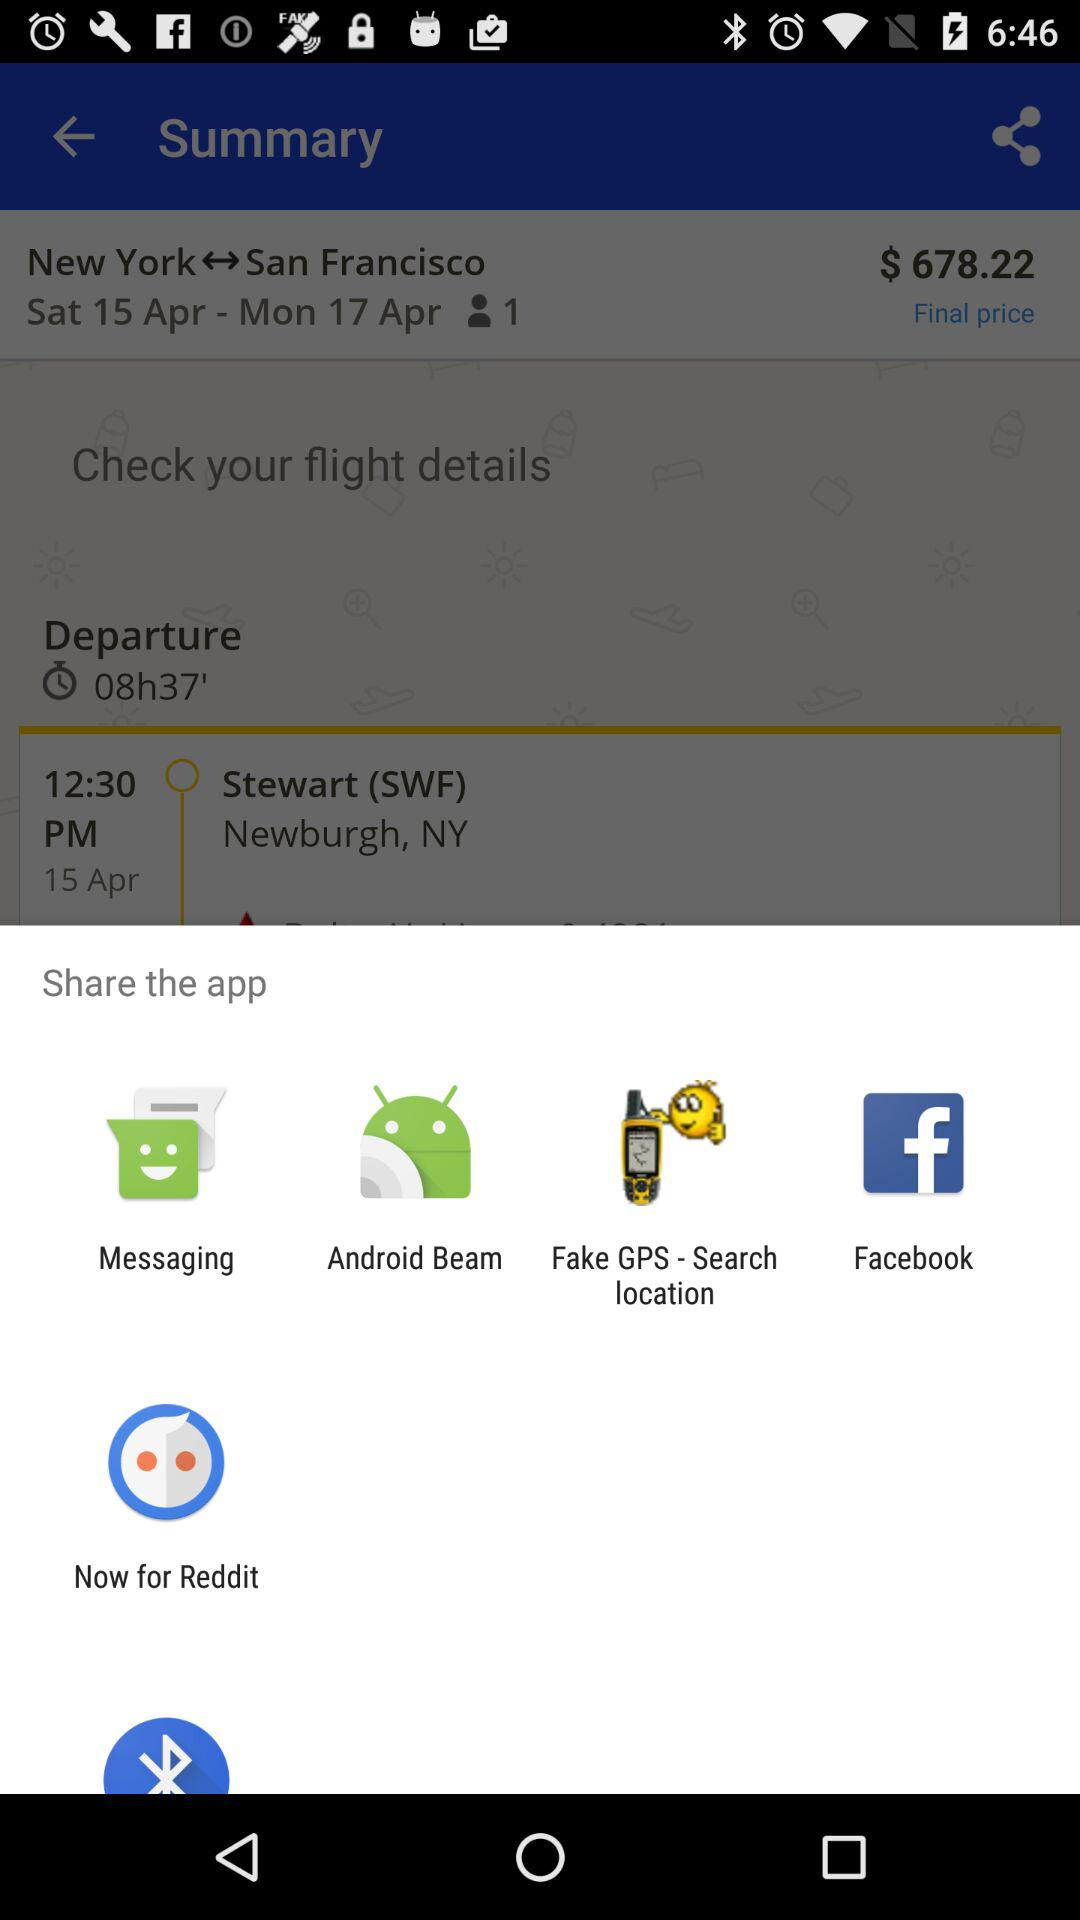What is the departure time for the flight from New York? The departure time is 12:30 PM. 